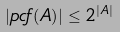Convert formula to latex. <formula><loc_0><loc_0><loc_500><loc_500>| { p c f } ( A ) | \leq 2 ^ { | A | }</formula> 